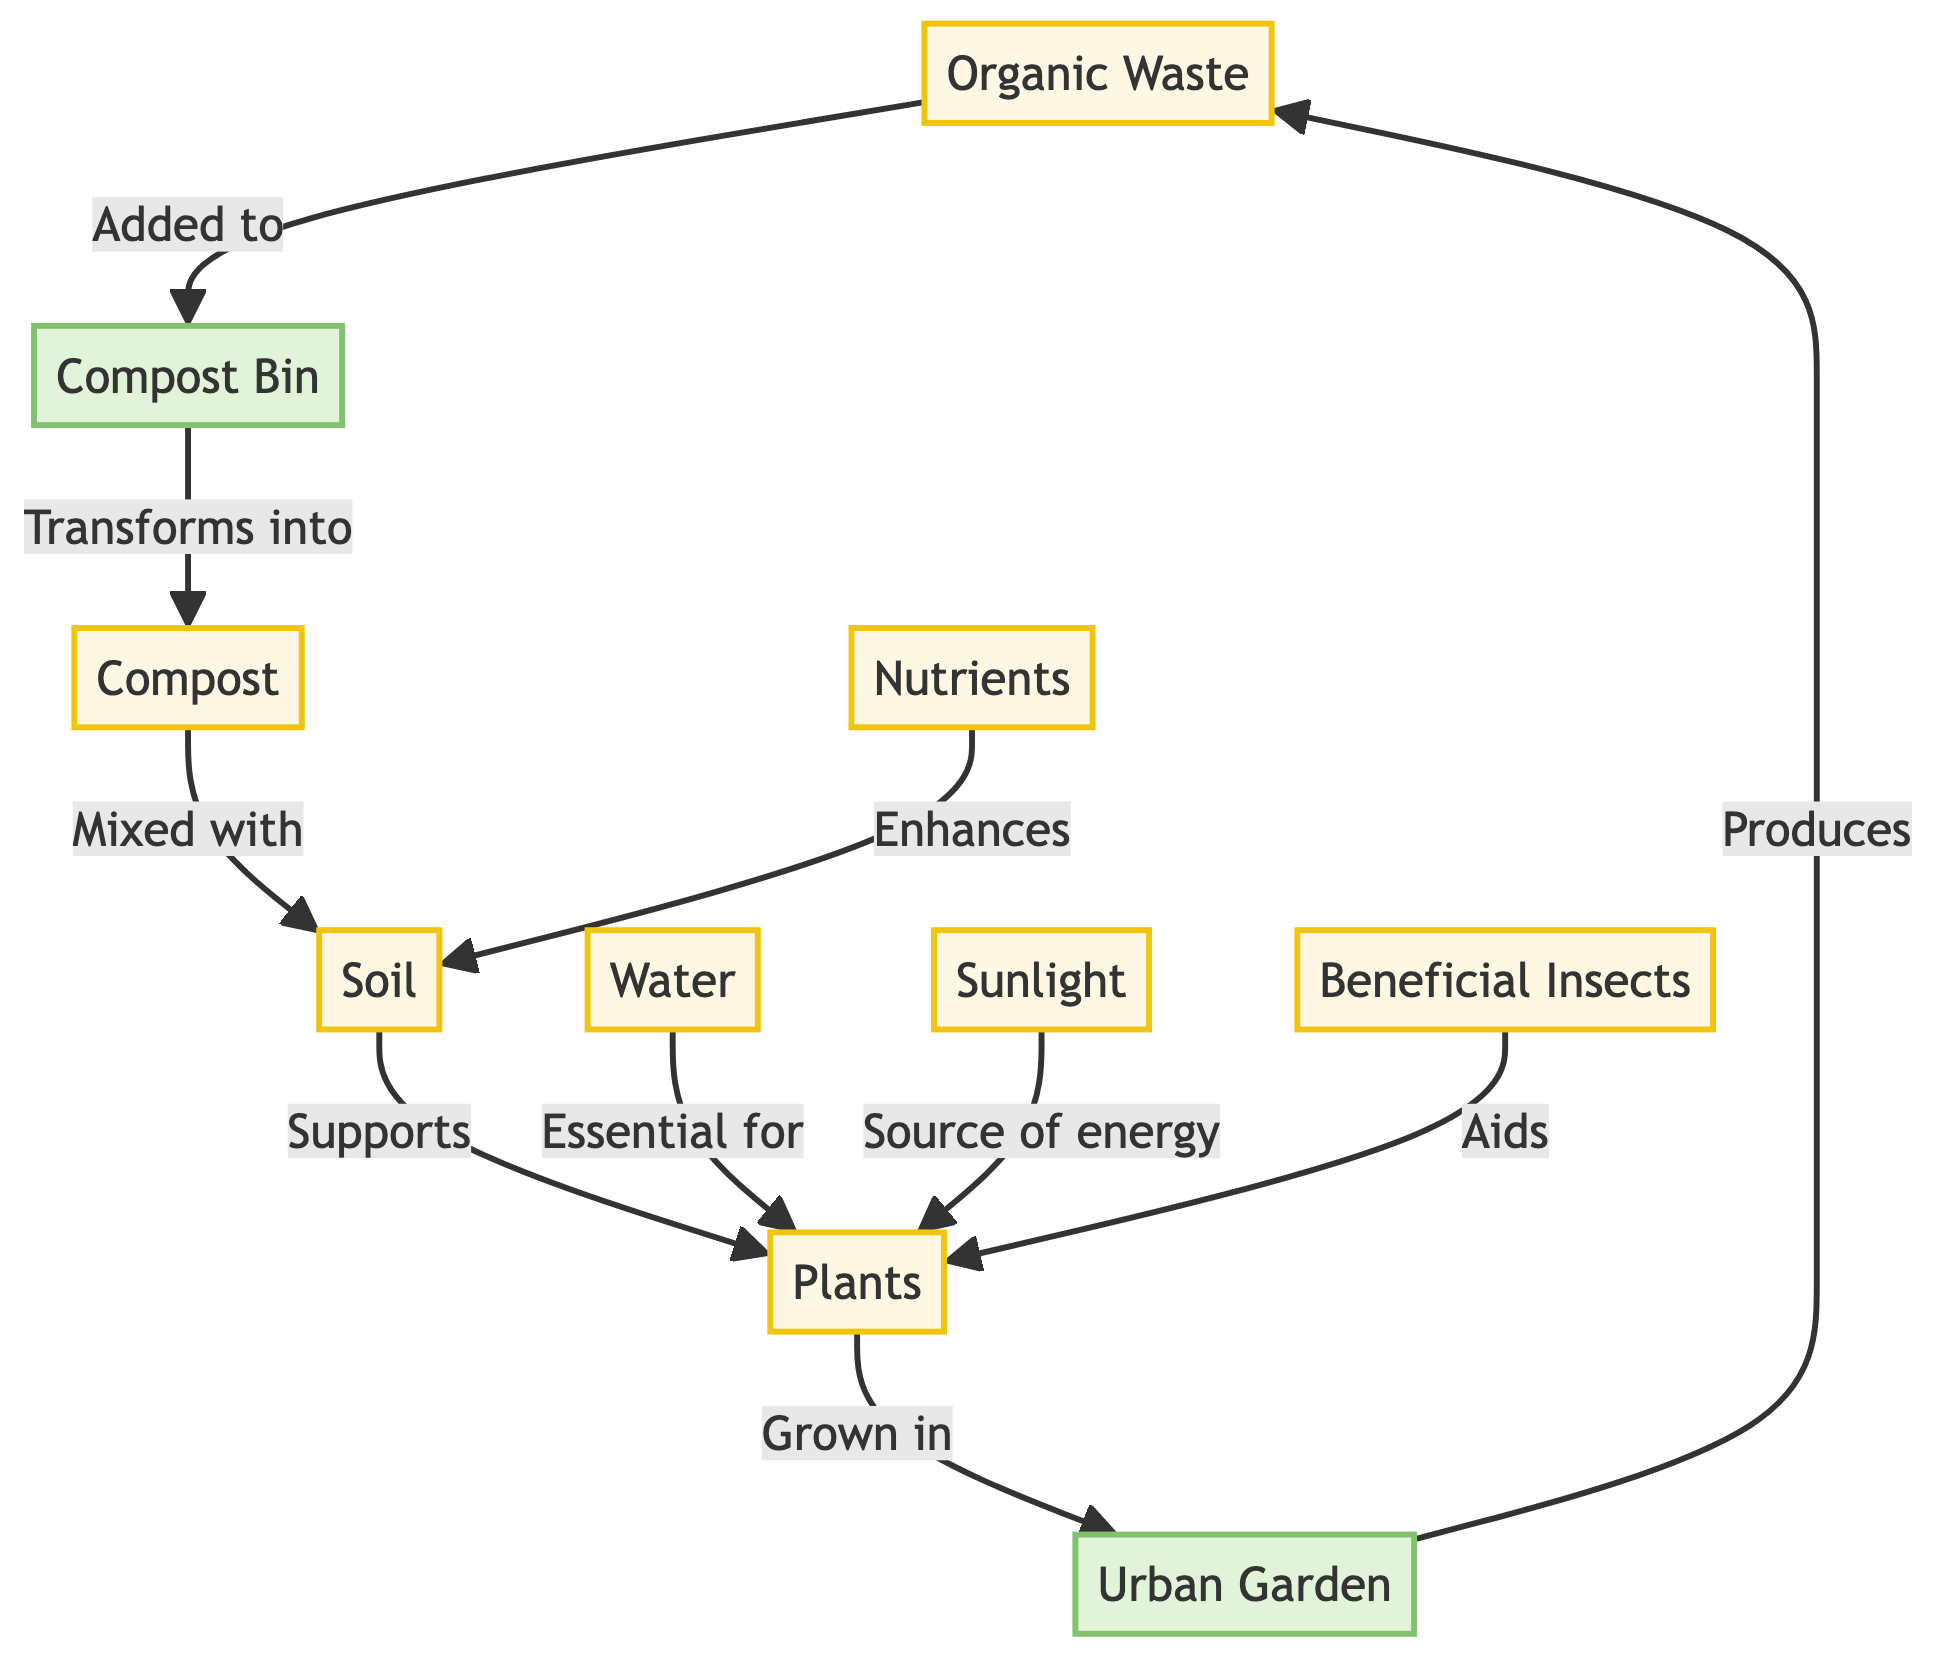What are the resources indicated in the diagram? The diagram includes multiple resources which can be identified as nodes. They are listed as Organic Waste, Compost, Soil, Plants, Nutrients, Water, Sunlight, and Beneficial Insects. Therefore, there are seven resources indicated in total.
Answer: Organic Waste, Compost, Soil, Plants, Nutrients, Water, Sunlight, Beneficial Insects How many main processes are there in the diagram? The diagram lists two explicit processes, which are Compost Bin and Urban Garden. While other components contribute to the flow, only these two are defined as processes according to the diagram's labeling.
Answer: Two What supports plant growth according to the diagram? The diagram explicitly shows that Soil supports Plants, and it lists other resources like Nutrients, Water, and Sunlight that also contribute to plant growth. By following the flow, we can identify Soil as the primary support.
Answer: Soil What is transformed into compost? Organic Waste is indicated as the primary input that is added to the Compost Bin, where it undergoes transformation to become Compost. This relationship is directly shown in the diagram's flow.
Answer: Organic Waste Which resources are essential for plants? The diagram establishes that Water and Sunlight are essential for Plants, which supports their growth. By examining the edges connecting these resources, we can determine their importance.
Answer: Water, Sunlight How do Urban Gardens contribute back to the nutrient cycle? The diagram shows that Urban Gardens produce Organic Waste, which is a crucial element that initiates the cycle. The flow indicates that Plants grown in Urban Gardens subsequently lead to the generation of more Organic Waste.
Answer: Organic Waste What aids plant growth besides Soil according to the diagram? Beneficial Insects is mentioned in the diagram as a resource that aids plant growth. The flow indicates that these insects contribute positively alongside other resources like Nutrients, Water, and Sunlight.
Answer: Beneficial Insects What relationship exists between Compost and Soil? According to the diagram, the relationship established is that Compost is mixed with Soil. This relationship indicates the transformation and utility of composted materials to enhance soil quality.
Answer: Mixed with How many connections or edges are there in the diagram? By counting the directed edges in the diagram, we can identify that there are ten connections or edges indicating the flow of the nutrient cycle among the resources and processes.
Answer: Ten 